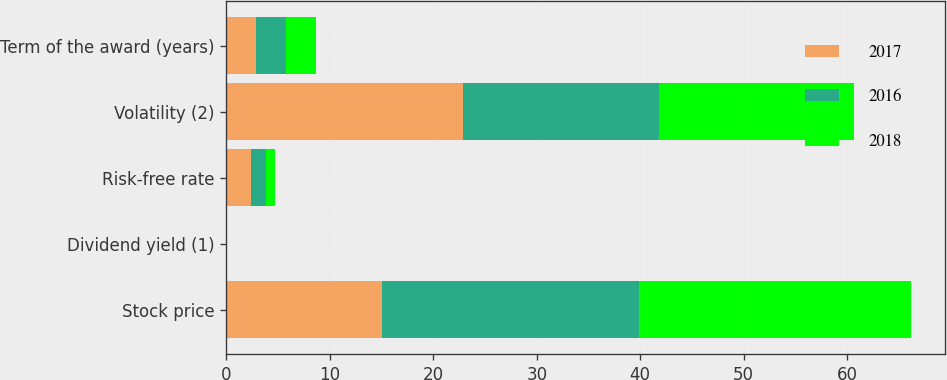<chart> <loc_0><loc_0><loc_500><loc_500><stacked_bar_chart><ecel><fcel>Stock price<fcel>Dividend yield (1)<fcel>Risk-free rate<fcel>Volatility (2)<fcel>Term of the award (years)<nl><fcel>2017<fcel>14.99<fcel>0<fcel>2.39<fcel>22.9<fcel>2.85<nl><fcel>2016<fcel>24.91<fcel>0<fcel>1.45<fcel>18.93<fcel>2.88<nl><fcel>2018<fcel>26.29<fcel>0<fcel>0.87<fcel>18.8<fcel>2.88<nl></chart> 